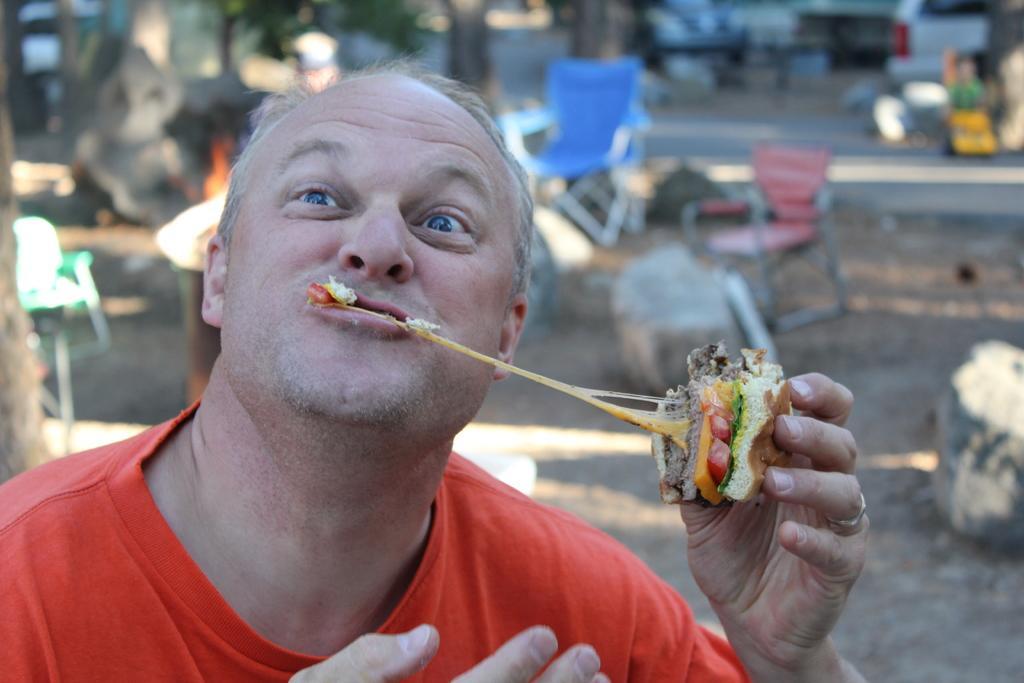How would you summarize this image in a sentence or two? In this image, we can see a person is holding some food item and eating. Background there is a blur view. Here we can see chairs, stones, road, some vehicle, few objects. 